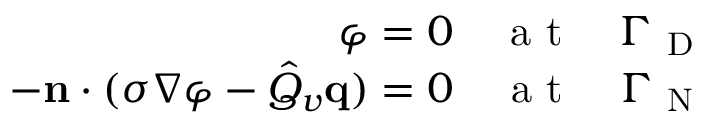Convert formula to latex. <formula><loc_0><loc_0><loc_500><loc_500>\begin{array} { r } { \varphi = 0 \quad a t \quad \Gamma _ { D } } \\ { - n \cdot ( \sigma \nabla \varphi - \hat { Q } _ { v } q ) = 0 \quad a t \quad \Gamma _ { N } } \end{array}</formula> 